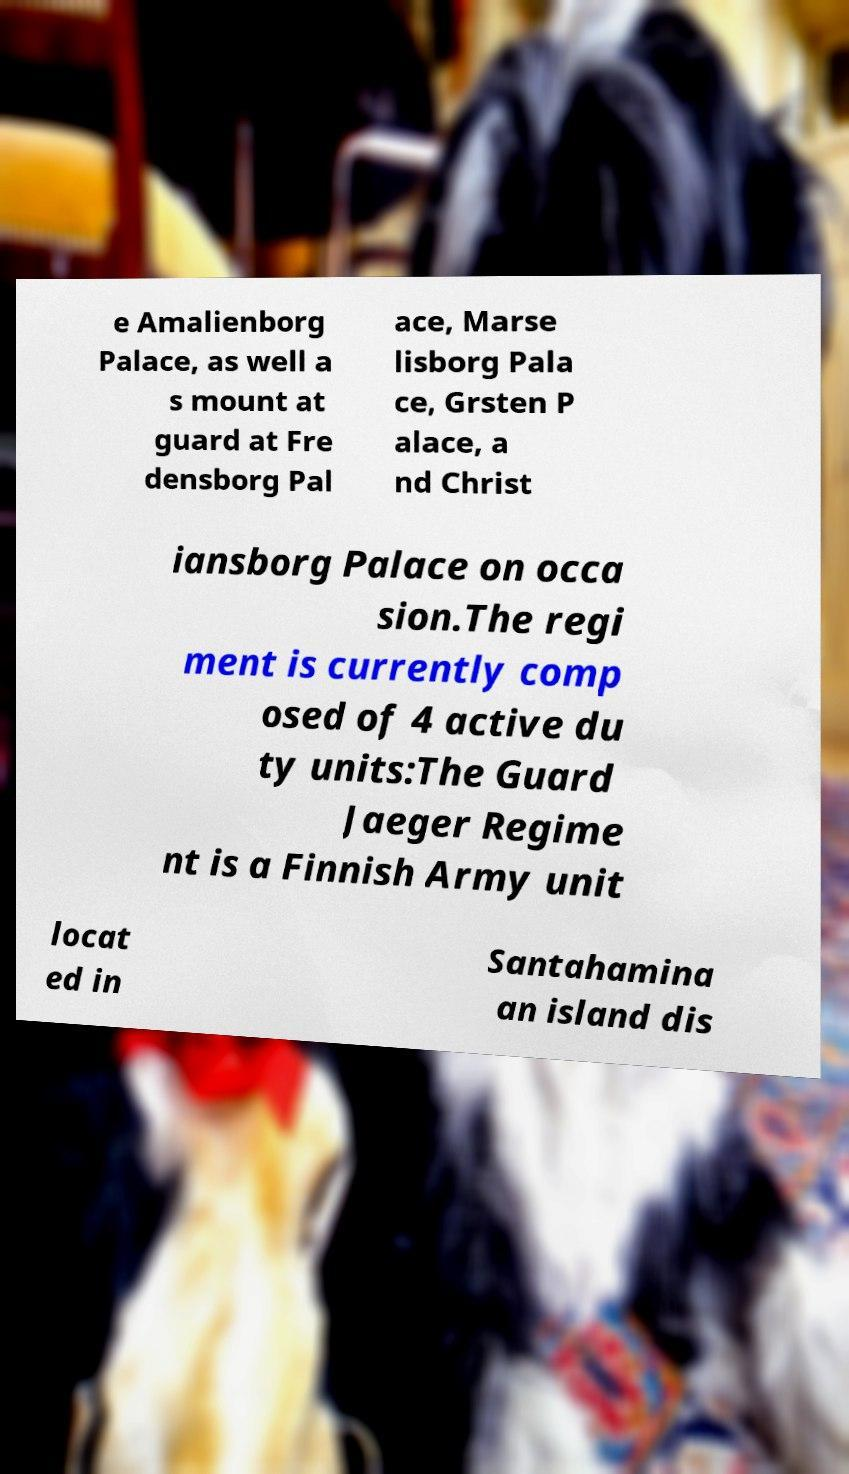What messages or text are displayed in this image? I need them in a readable, typed format. e Amalienborg Palace, as well a s mount at guard at Fre densborg Pal ace, Marse lisborg Pala ce, Grsten P alace, a nd Christ iansborg Palace on occa sion.The regi ment is currently comp osed of 4 active du ty units:The Guard Jaeger Regime nt is a Finnish Army unit locat ed in Santahamina an island dis 